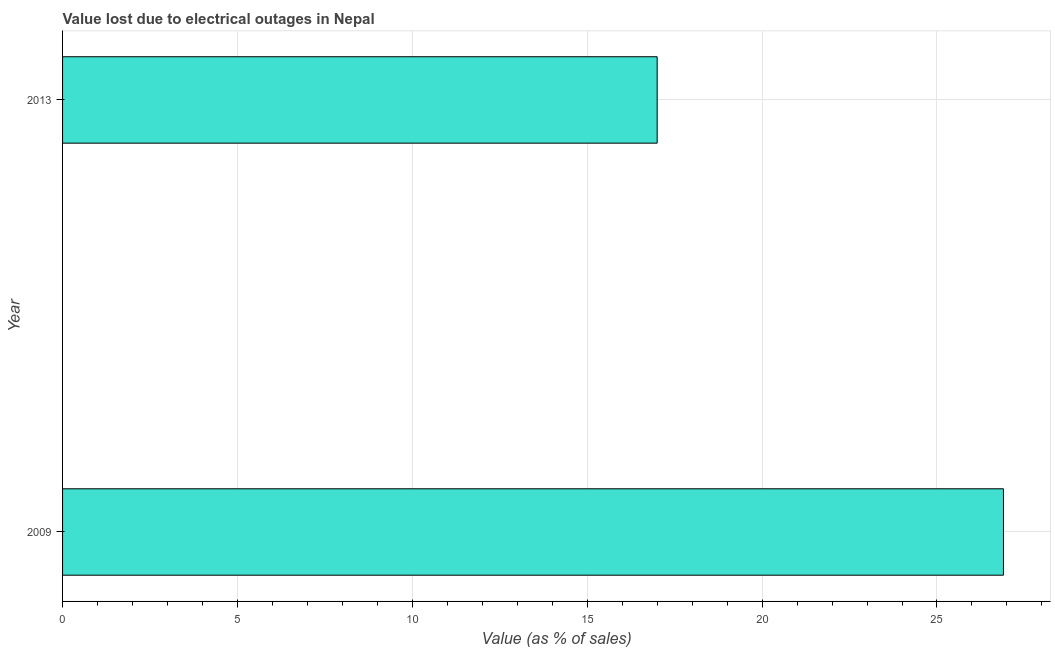Does the graph contain grids?
Ensure brevity in your answer.  Yes. What is the title of the graph?
Your answer should be compact. Value lost due to electrical outages in Nepal. What is the label or title of the X-axis?
Make the answer very short. Value (as % of sales). What is the label or title of the Y-axis?
Provide a succinct answer. Year. Across all years, what is the maximum value lost due to electrical outages?
Keep it short and to the point. 26.9. In which year was the value lost due to electrical outages minimum?
Give a very brief answer. 2013. What is the sum of the value lost due to electrical outages?
Offer a terse response. 43.9. What is the difference between the value lost due to electrical outages in 2009 and 2013?
Your response must be concise. 9.9. What is the average value lost due to electrical outages per year?
Your answer should be very brief. 21.95. What is the median value lost due to electrical outages?
Your answer should be very brief. 21.95. In how many years, is the value lost due to electrical outages greater than 23 %?
Provide a short and direct response. 1. Do a majority of the years between 2009 and 2013 (inclusive) have value lost due to electrical outages greater than 7 %?
Provide a succinct answer. Yes. What is the ratio of the value lost due to electrical outages in 2009 to that in 2013?
Your response must be concise. 1.58. Is the value lost due to electrical outages in 2009 less than that in 2013?
Ensure brevity in your answer.  No. In how many years, is the value lost due to electrical outages greater than the average value lost due to electrical outages taken over all years?
Offer a terse response. 1. How many bars are there?
Make the answer very short. 2. Are all the bars in the graph horizontal?
Offer a very short reply. Yes. What is the Value (as % of sales) of 2009?
Provide a succinct answer. 26.9. What is the Value (as % of sales) in 2013?
Offer a very short reply. 17. What is the difference between the Value (as % of sales) in 2009 and 2013?
Your answer should be very brief. 9.9. What is the ratio of the Value (as % of sales) in 2009 to that in 2013?
Give a very brief answer. 1.58. 